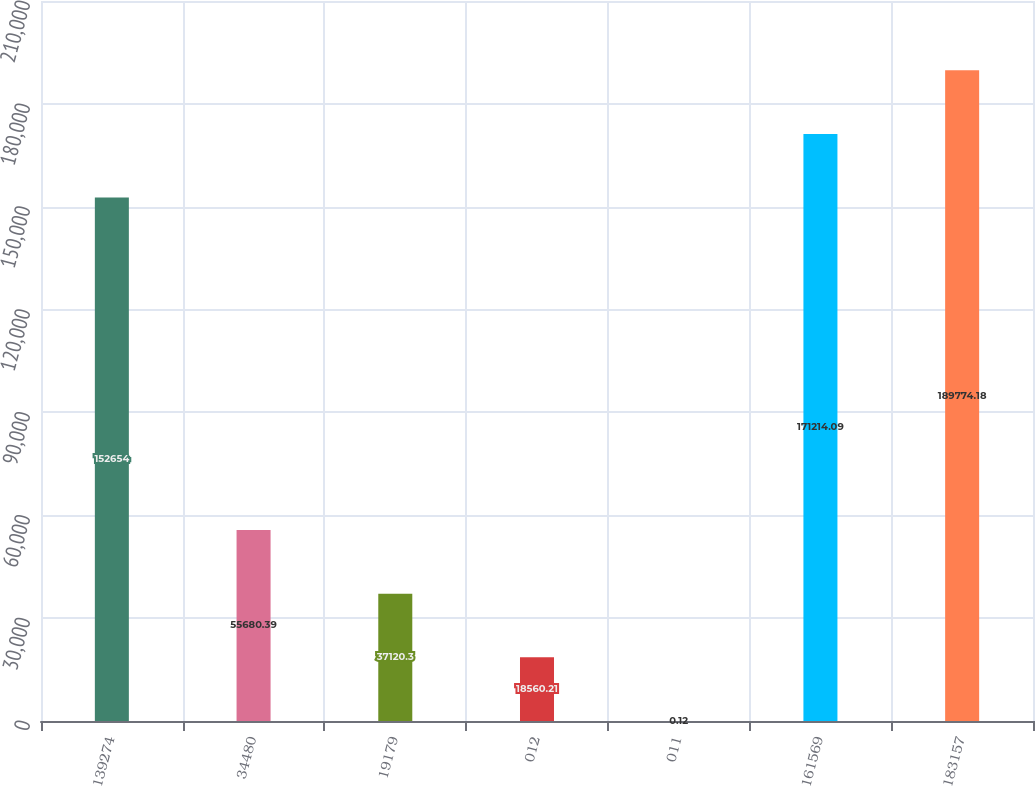Convert chart to OTSL. <chart><loc_0><loc_0><loc_500><loc_500><bar_chart><fcel>139274<fcel>34480<fcel>19179<fcel>012<fcel>011<fcel>161569<fcel>183157<nl><fcel>152654<fcel>55680.4<fcel>37120.3<fcel>18560.2<fcel>0.12<fcel>171214<fcel>189774<nl></chart> 